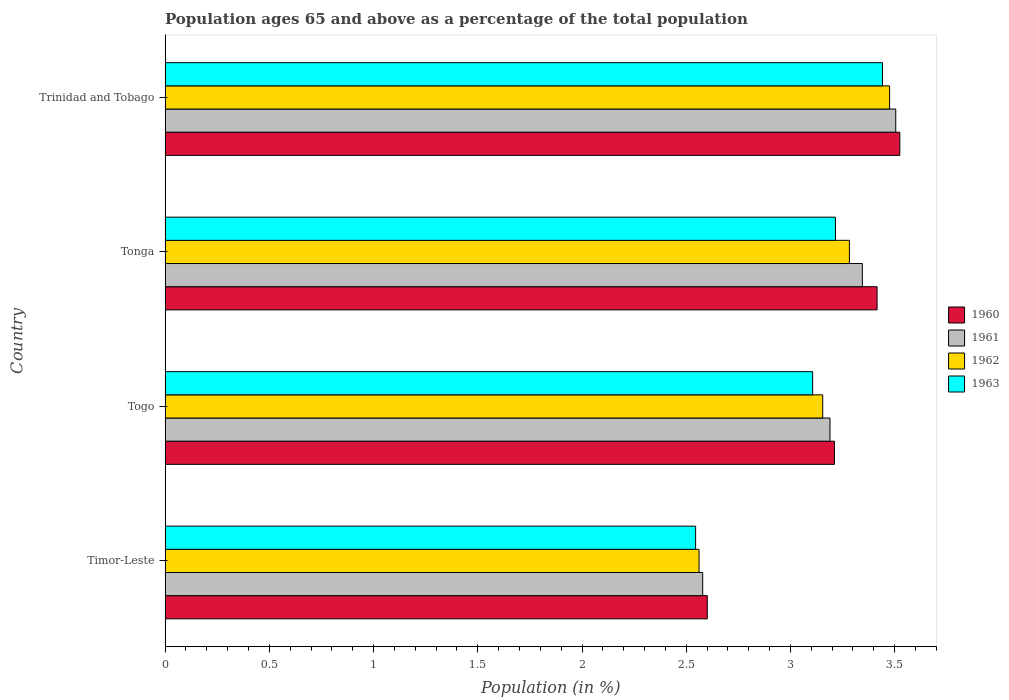Are the number of bars per tick equal to the number of legend labels?
Offer a very short reply. Yes. How many bars are there on the 4th tick from the bottom?
Your answer should be very brief. 4. What is the label of the 4th group of bars from the top?
Offer a terse response. Timor-Leste. What is the percentage of the population ages 65 and above in 1962 in Timor-Leste?
Provide a succinct answer. 2.56. Across all countries, what is the maximum percentage of the population ages 65 and above in 1961?
Give a very brief answer. 3.51. Across all countries, what is the minimum percentage of the population ages 65 and above in 1961?
Keep it short and to the point. 2.58. In which country was the percentage of the population ages 65 and above in 1962 maximum?
Offer a very short reply. Trinidad and Tobago. In which country was the percentage of the population ages 65 and above in 1960 minimum?
Provide a short and direct response. Timor-Leste. What is the total percentage of the population ages 65 and above in 1960 in the graph?
Offer a very short reply. 12.75. What is the difference between the percentage of the population ages 65 and above in 1961 in Timor-Leste and that in Trinidad and Tobago?
Your response must be concise. -0.93. What is the difference between the percentage of the population ages 65 and above in 1961 in Togo and the percentage of the population ages 65 and above in 1962 in Timor-Leste?
Provide a short and direct response. 0.63. What is the average percentage of the population ages 65 and above in 1963 per country?
Give a very brief answer. 3.08. What is the difference between the percentage of the population ages 65 and above in 1961 and percentage of the population ages 65 and above in 1963 in Timor-Leste?
Offer a very short reply. 0.03. In how many countries, is the percentage of the population ages 65 and above in 1961 greater than 1.6 ?
Your answer should be compact. 4. What is the ratio of the percentage of the population ages 65 and above in 1961 in Timor-Leste to that in Tonga?
Your answer should be compact. 0.77. Is the percentage of the population ages 65 and above in 1963 in Timor-Leste less than that in Togo?
Your response must be concise. Yes. What is the difference between the highest and the second highest percentage of the population ages 65 and above in 1961?
Your answer should be compact. 0.16. What is the difference between the highest and the lowest percentage of the population ages 65 and above in 1960?
Keep it short and to the point. 0.92. In how many countries, is the percentage of the population ages 65 and above in 1960 greater than the average percentage of the population ages 65 and above in 1960 taken over all countries?
Your response must be concise. 3. Is the sum of the percentage of the population ages 65 and above in 1961 in Timor-Leste and Tonga greater than the maximum percentage of the population ages 65 and above in 1963 across all countries?
Provide a succinct answer. Yes. What does the 3rd bar from the bottom in Togo represents?
Provide a short and direct response. 1962. Is it the case that in every country, the sum of the percentage of the population ages 65 and above in 1960 and percentage of the population ages 65 and above in 1961 is greater than the percentage of the population ages 65 and above in 1962?
Ensure brevity in your answer.  Yes. How many countries are there in the graph?
Provide a succinct answer. 4. What is the difference between two consecutive major ticks on the X-axis?
Keep it short and to the point. 0.5. Does the graph contain any zero values?
Make the answer very short. No. Does the graph contain grids?
Keep it short and to the point. No. How many legend labels are there?
Make the answer very short. 4. How are the legend labels stacked?
Your response must be concise. Vertical. What is the title of the graph?
Offer a terse response. Population ages 65 and above as a percentage of the total population. Does "2005" appear as one of the legend labels in the graph?
Offer a very short reply. No. What is the label or title of the Y-axis?
Provide a short and direct response. Country. What is the Population (in %) in 1960 in Timor-Leste?
Your answer should be very brief. 2.6. What is the Population (in %) of 1961 in Timor-Leste?
Ensure brevity in your answer.  2.58. What is the Population (in %) of 1962 in Timor-Leste?
Offer a very short reply. 2.56. What is the Population (in %) in 1963 in Timor-Leste?
Your answer should be compact. 2.55. What is the Population (in %) in 1960 in Togo?
Keep it short and to the point. 3.21. What is the Population (in %) in 1961 in Togo?
Keep it short and to the point. 3.19. What is the Population (in %) in 1962 in Togo?
Offer a terse response. 3.15. What is the Population (in %) in 1963 in Togo?
Provide a short and direct response. 3.11. What is the Population (in %) in 1960 in Tonga?
Your answer should be very brief. 3.42. What is the Population (in %) in 1961 in Tonga?
Provide a short and direct response. 3.34. What is the Population (in %) in 1962 in Tonga?
Offer a very short reply. 3.28. What is the Population (in %) in 1963 in Tonga?
Provide a succinct answer. 3.22. What is the Population (in %) of 1960 in Trinidad and Tobago?
Offer a terse response. 3.52. What is the Population (in %) of 1961 in Trinidad and Tobago?
Ensure brevity in your answer.  3.51. What is the Population (in %) of 1962 in Trinidad and Tobago?
Offer a very short reply. 3.48. What is the Population (in %) of 1963 in Trinidad and Tobago?
Give a very brief answer. 3.44. Across all countries, what is the maximum Population (in %) in 1960?
Your response must be concise. 3.52. Across all countries, what is the maximum Population (in %) of 1961?
Your response must be concise. 3.51. Across all countries, what is the maximum Population (in %) in 1962?
Make the answer very short. 3.48. Across all countries, what is the maximum Population (in %) of 1963?
Ensure brevity in your answer.  3.44. Across all countries, what is the minimum Population (in %) of 1960?
Your response must be concise. 2.6. Across all countries, what is the minimum Population (in %) in 1961?
Your answer should be very brief. 2.58. Across all countries, what is the minimum Population (in %) in 1962?
Offer a terse response. 2.56. Across all countries, what is the minimum Population (in %) of 1963?
Offer a terse response. 2.55. What is the total Population (in %) in 1960 in the graph?
Give a very brief answer. 12.75. What is the total Population (in %) in 1961 in the graph?
Ensure brevity in your answer.  12.62. What is the total Population (in %) of 1962 in the graph?
Offer a very short reply. 12.47. What is the total Population (in %) in 1963 in the graph?
Offer a very short reply. 12.31. What is the difference between the Population (in %) of 1960 in Timor-Leste and that in Togo?
Offer a very short reply. -0.61. What is the difference between the Population (in %) of 1961 in Timor-Leste and that in Togo?
Your response must be concise. -0.61. What is the difference between the Population (in %) in 1962 in Timor-Leste and that in Togo?
Your answer should be very brief. -0.59. What is the difference between the Population (in %) in 1963 in Timor-Leste and that in Togo?
Keep it short and to the point. -0.56. What is the difference between the Population (in %) of 1960 in Timor-Leste and that in Tonga?
Your answer should be compact. -0.81. What is the difference between the Population (in %) of 1961 in Timor-Leste and that in Tonga?
Offer a terse response. -0.77. What is the difference between the Population (in %) of 1962 in Timor-Leste and that in Tonga?
Ensure brevity in your answer.  -0.72. What is the difference between the Population (in %) of 1963 in Timor-Leste and that in Tonga?
Ensure brevity in your answer.  -0.67. What is the difference between the Population (in %) of 1960 in Timor-Leste and that in Trinidad and Tobago?
Provide a short and direct response. -0.92. What is the difference between the Population (in %) of 1961 in Timor-Leste and that in Trinidad and Tobago?
Give a very brief answer. -0.93. What is the difference between the Population (in %) in 1962 in Timor-Leste and that in Trinidad and Tobago?
Your response must be concise. -0.91. What is the difference between the Population (in %) in 1963 in Timor-Leste and that in Trinidad and Tobago?
Give a very brief answer. -0.9. What is the difference between the Population (in %) in 1960 in Togo and that in Tonga?
Give a very brief answer. -0.2. What is the difference between the Population (in %) in 1961 in Togo and that in Tonga?
Provide a short and direct response. -0.16. What is the difference between the Population (in %) of 1962 in Togo and that in Tonga?
Your answer should be compact. -0.13. What is the difference between the Population (in %) in 1963 in Togo and that in Tonga?
Offer a terse response. -0.11. What is the difference between the Population (in %) of 1960 in Togo and that in Trinidad and Tobago?
Ensure brevity in your answer.  -0.31. What is the difference between the Population (in %) in 1961 in Togo and that in Trinidad and Tobago?
Your response must be concise. -0.32. What is the difference between the Population (in %) in 1962 in Togo and that in Trinidad and Tobago?
Offer a terse response. -0.32. What is the difference between the Population (in %) in 1963 in Togo and that in Trinidad and Tobago?
Your response must be concise. -0.34. What is the difference between the Population (in %) of 1960 in Tonga and that in Trinidad and Tobago?
Your answer should be compact. -0.11. What is the difference between the Population (in %) of 1961 in Tonga and that in Trinidad and Tobago?
Keep it short and to the point. -0.16. What is the difference between the Population (in %) of 1962 in Tonga and that in Trinidad and Tobago?
Offer a terse response. -0.19. What is the difference between the Population (in %) in 1963 in Tonga and that in Trinidad and Tobago?
Your response must be concise. -0.23. What is the difference between the Population (in %) in 1960 in Timor-Leste and the Population (in %) in 1961 in Togo?
Offer a very short reply. -0.59. What is the difference between the Population (in %) in 1960 in Timor-Leste and the Population (in %) in 1962 in Togo?
Your answer should be very brief. -0.55. What is the difference between the Population (in %) in 1960 in Timor-Leste and the Population (in %) in 1963 in Togo?
Your answer should be very brief. -0.51. What is the difference between the Population (in %) in 1961 in Timor-Leste and the Population (in %) in 1962 in Togo?
Your response must be concise. -0.58. What is the difference between the Population (in %) of 1961 in Timor-Leste and the Population (in %) of 1963 in Togo?
Ensure brevity in your answer.  -0.53. What is the difference between the Population (in %) of 1962 in Timor-Leste and the Population (in %) of 1963 in Togo?
Ensure brevity in your answer.  -0.55. What is the difference between the Population (in %) of 1960 in Timor-Leste and the Population (in %) of 1961 in Tonga?
Your answer should be compact. -0.74. What is the difference between the Population (in %) in 1960 in Timor-Leste and the Population (in %) in 1962 in Tonga?
Keep it short and to the point. -0.68. What is the difference between the Population (in %) of 1960 in Timor-Leste and the Population (in %) of 1963 in Tonga?
Your answer should be very brief. -0.61. What is the difference between the Population (in %) in 1961 in Timor-Leste and the Population (in %) in 1962 in Tonga?
Your answer should be very brief. -0.7. What is the difference between the Population (in %) of 1961 in Timor-Leste and the Population (in %) of 1963 in Tonga?
Give a very brief answer. -0.64. What is the difference between the Population (in %) of 1962 in Timor-Leste and the Population (in %) of 1963 in Tonga?
Give a very brief answer. -0.65. What is the difference between the Population (in %) in 1960 in Timor-Leste and the Population (in %) in 1961 in Trinidad and Tobago?
Offer a very short reply. -0.9. What is the difference between the Population (in %) in 1960 in Timor-Leste and the Population (in %) in 1962 in Trinidad and Tobago?
Offer a terse response. -0.87. What is the difference between the Population (in %) in 1960 in Timor-Leste and the Population (in %) in 1963 in Trinidad and Tobago?
Offer a terse response. -0.84. What is the difference between the Population (in %) of 1961 in Timor-Leste and the Population (in %) of 1962 in Trinidad and Tobago?
Provide a short and direct response. -0.9. What is the difference between the Population (in %) in 1961 in Timor-Leste and the Population (in %) in 1963 in Trinidad and Tobago?
Your answer should be compact. -0.86. What is the difference between the Population (in %) in 1962 in Timor-Leste and the Population (in %) in 1963 in Trinidad and Tobago?
Ensure brevity in your answer.  -0.88. What is the difference between the Population (in %) in 1960 in Togo and the Population (in %) in 1961 in Tonga?
Ensure brevity in your answer.  -0.13. What is the difference between the Population (in %) of 1960 in Togo and the Population (in %) of 1962 in Tonga?
Keep it short and to the point. -0.07. What is the difference between the Population (in %) of 1960 in Togo and the Population (in %) of 1963 in Tonga?
Your answer should be compact. -0. What is the difference between the Population (in %) in 1961 in Togo and the Population (in %) in 1962 in Tonga?
Provide a succinct answer. -0.09. What is the difference between the Population (in %) of 1961 in Togo and the Population (in %) of 1963 in Tonga?
Keep it short and to the point. -0.03. What is the difference between the Population (in %) of 1962 in Togo and the Population (in %) of 1963 in Tonga?
Your answer should be very brief. -0.06. What is the difference between the Population (in %) of 1960 in Togo and the Population (in %) of 1961 in Trinidad and Tobago?
Offer a terse response. -0.29. What is the difference between the Population (in %) in 1960 in Togo and the Population (in %) in 1962 in Trinidad and Tobago?
Make the answer very short. -0.26. What is the difference between the Population (in %) in 1960 in Togo and the Population (in %) in 1963 in Trinidad and Tobago?
Ensure brevity in your answer.  -0.23. What is the difference between the Population (in %) in 1961 in Togo and the Population (in %) in 1962 in Trinidad and Tobago?
Your answer should be very brief. -0.29. What is the difference between the Population (in %) in 1961 in Togo and the Population (in %) in 1963 in Trinidad and Tobago?
Your answer should be very brief. -0.25. What is the difference between the Population (in %) of 1962 in Togo and the Population (in %) of 1963 in Trinidad and Tobago?
Make the answer very short. -0.29. What is the difference between the Population (in %) of 1960 in Tonga and the Population (in %) of 1961 in Trinidad and Tobago?
Keep it short and to the point. -0.09. What is the difference between the Population (in %) of 1960 in Tonga and the Population (in %) of 1962 in Trinidad and Tobago?
Your answer should be very brief. -0.06. What is the difference between the Population (in %) in 1960 in Tonga and the Population (in %) in 1963 in Trinidad and Tobago?
Give a very brief answer. -0.03. What is the difference between the Population (in %) in 1961 in Tonga and the Population (in %) in 1962 in Trinidad and Tobago?
Your answer should be compact. -0.13. What is the difference between the Population (in %) of 1961 in Tonga and the Population (in %) of 1963 in Trinidad and Tobago?
Your answer should be compact. -0.1. What is the difference between the Population (in %) in 1962 in Tonga and the Population (in %) in 1963 in Trinidad and Tobago?
Make the answer very short. -0.16. What is the average Population (in %) of 1960 per country?
Provide a short and direct response. 3.19. What is the average Population (in %) of 1961 per country?
Keep it short and to the point. 3.15. What is the average Population (in %) of 1962 per country?
Ensure brevity in your answer.  3.12. What is the average Population (in %) in 1963 per country?
Keep it short and to the point. 3.08. What is the difference between the Population (in %) of 1960 and Population (in %) of 1961 in Timor-Leste?
Give a very brief answer. 0.02. What is the difference between the Population (in %) of 1960 and Population (in %) of 1962 in Timor-Leste?
Offer a very short reply. 0.04. What is the difference between the Population (in %) of 1960 and Population (in %) of 1963 in Timor-Leste?
Ensure brevity in your answer.  0.06. What is the difference between the Population (in %) in 1961 and Population (in %) in 1962 in Timor-Leste?
Your answer should be compact. 0.02. What is the difference between the Population (in %) of 1961 and Population (in %) of 1963 in Timor-Leste?
Give a very brief answer. 0.03. What is the difference between the Population (in %) in 1962 and Population (in %) in 1963 in Timor-Leste?
Your answer should be very brief. 0.02. What is the difference between the Population (in %) in 1960 and Population (in %) in 1961 in Togo?
Ensure brevity in your answer.  0.02. What is the difference between the Population (in %) in 1960 and Population (in %) in 1962 in Togo?
Offer a terse response. 0.06. What is the difference between the Population (in %) of 1960 and Population (in %) of 1963 in Togo?
Offer a very short reply. 0.1. What is the difference between the Population (in %) in 1961 and Population (in %) in 1962 in Togo?
Offer a terse response. 0.04. What is the difference between the Population (in %) of 1961 and Population (in %) of 1963 in Togo?
Offer a terse response. 0.08. What is the difference between the Population (in %) of 1962 and Population (in %) of 1963 in Togo?
Offer a terse response. 0.05. What is the difference between the Population (in %) in 1960 and Population (in %) in 1961 in Tonga?
Your response must be concise. 0.07. What is the difference between the Population (in %) in 1960 and Population (in %) in 1962 in Tonga?
Offer a terse response. 0.13. What is the difference between the Population (in %) of 1960 and Population (in %) of 1963 in Tonga?
Offer a very short reply. 0.2. What is the difference between the Population (in %) in 1961 and Population (in %) in 1962 in Tonga?
Provide a short and direct response. 0.06. What is the difference between the Population (in %) of 1961 and Population (in %) of 1963 in Tonga?
Your answer should be compact. 0.13. What is the difference between the Population (in %) in 1962 and Population (in %) in 1963 in Tonga?
Your response must be concise. 0.07. What is the difference between the Population (in %) in 1960 and Population (in %) in 1961 in Trinidad and Tobago?
Give a very brief answer. 0.02. What is the difference between the Population (in %) in 1960 and Population (in %) in 1962 in Trinidad and Tobago?
Give a very brief answer. 0.05. What is the difference between the Population (in %) of 1960 and Population (in %) of 1963 in Trinidad and Tobago?
Provide a short and direct response. 0.08. What is the difference between the Population (in %) in 1961 and Population (in %) in 1962 in Trinidad and Tobago?
Provide a succinct answer. 0.03. What is the difference between the Population (in %) in 1961 and Population (in %) in 1963 in Trinidad and Tobago?
Your answer should be very brief. 0.06. What is the difference between the Population (in %) of 1962 and Population (in %) of 1963 in Trinidad and Tobago?
Ensure brevity in your answer.  0.03. What is the ratio of the Population (in %) of 1960 in Timor-Leste to that in Togo?
Your answer should be compact. 0.81. What is the ratio of the Population (in %) of 1961 in Timor-Leste to that in Togo?
Your response must be concise. 0.81. What is the ratio of the Population (in %) in 1962 in Timor-Leste to that in Togo?
Your answer should be very brief. 0.81. What is the ratio of the Population (in %) of 1963 in Timor-Leste to that in Togo?
Your answer should be very brief. 0.82. What is the ratio of the Population (in %) in 1960 in Timor-Leste to that in Tonga?
Ensure brevity in your answer.  0.76. What is the ratio of the Population (in %) of 1961 in Timor-Leste to that in Tonga?
Offer a very short reply. 0.77. What is the ratio of the Population (in %) in 1962 in Timor-Leste to that in Tonga?
Ensure brevity in your answer.  0.78. What is the ratio of the Population (in %) of 1963 in Timor-Leste to that in Tonga?
Provide a succinct answer. 0.79. What is the ratio of the Population (in %) of 1960 in Timor-Leste to that in Trinidad and Tobago?
Provide a succinct answer. 0.74. What is the ratio of the Population (in %) in 1961 in Timor-Leste to that in Trinidad and Tobago?
Ensure brevity in your answer.  0.74. What is the ratio of the Population (in %) of 1962 in Timor-Leste to that in Trinidad and Tobago?
Give a very brief answer. 0.74. What is the ratio of the Population (in %) in 1963 in Timor-Leste to that in Trinidad and Tobago?
Offer a very short reply. 0.74. What is the ratio of the Population (in %) of 1960 in Togo to that in Tonga?
Provide a short and direct response. 0.94. What is the ratio of the Population (in %) of 1961 in Togo to that in Tonga?
Offer a terse response. 0.95. What is the ratio of the Population (in %) in 1960 in Togo to that in Trinidad and Tobago?
Provide a short and direct response. 0.91. What is the ratio of the Population (in %) in 1961 in Togo to that in Trinidad and Tobago?
Your response must be concise. 0.91. What is the ratio of the Population (in %) of 1962 in Togo to that in Trinidad and Tobago?
Make the answer very short. 0.91. What is the ratio of the Population (in %) in 1963 in Togo to that in Trinidad and Tobago?
Offer a terse response. 0.9. What is the ratio of the Population (in %) in 1960 in Tonga to that in Trinidad and Tobago?
Your answer should be very brief. 0.97. What is the ratio of the Population (in %) in 1961 in Tonga to that in Trinidad and Tobago?
Your answer should be very brief. 0.95. What is the ratio of the Population (in %) of 1962 in Tonga to that in Trinidad and Tobago?
Your answer should be very brief. 0.94. What is the ratio of the Population (in %) in 1963 in Tonga to that in Trinidad and Tobago?
Make the answer very short. 0.93. What is the difference between the highest and the second highest Population (in %) of 1960?
Your answer should be very brief. 0.11. What is the difference between the highest and the second highest Population (in %) in 1961?
Provide a short and direct response. 0.16. What is the difference between the highest and the second highest Population (in %) in 1962?
Ensure brevity in your answer.  0.19. What is the difference between the highest and the second highest Population (in %) of 1963?
Your answer should be very brief. 0.23. What is the difference between the highest and the lowest Population (in %) of 1960?
Provide a short and direct response. 0.92. What is the difference between the highest and the lowest Population (in %) of 1961?
Make the answer very short. 0.93. What is the difference between the highest and the lowest Population (in %) in 1962?
Keep it short and to the point. 0.91. What is the difference between the highest and the lowest Population (in %) in 1963?
Offer a terse response. 0.9. 